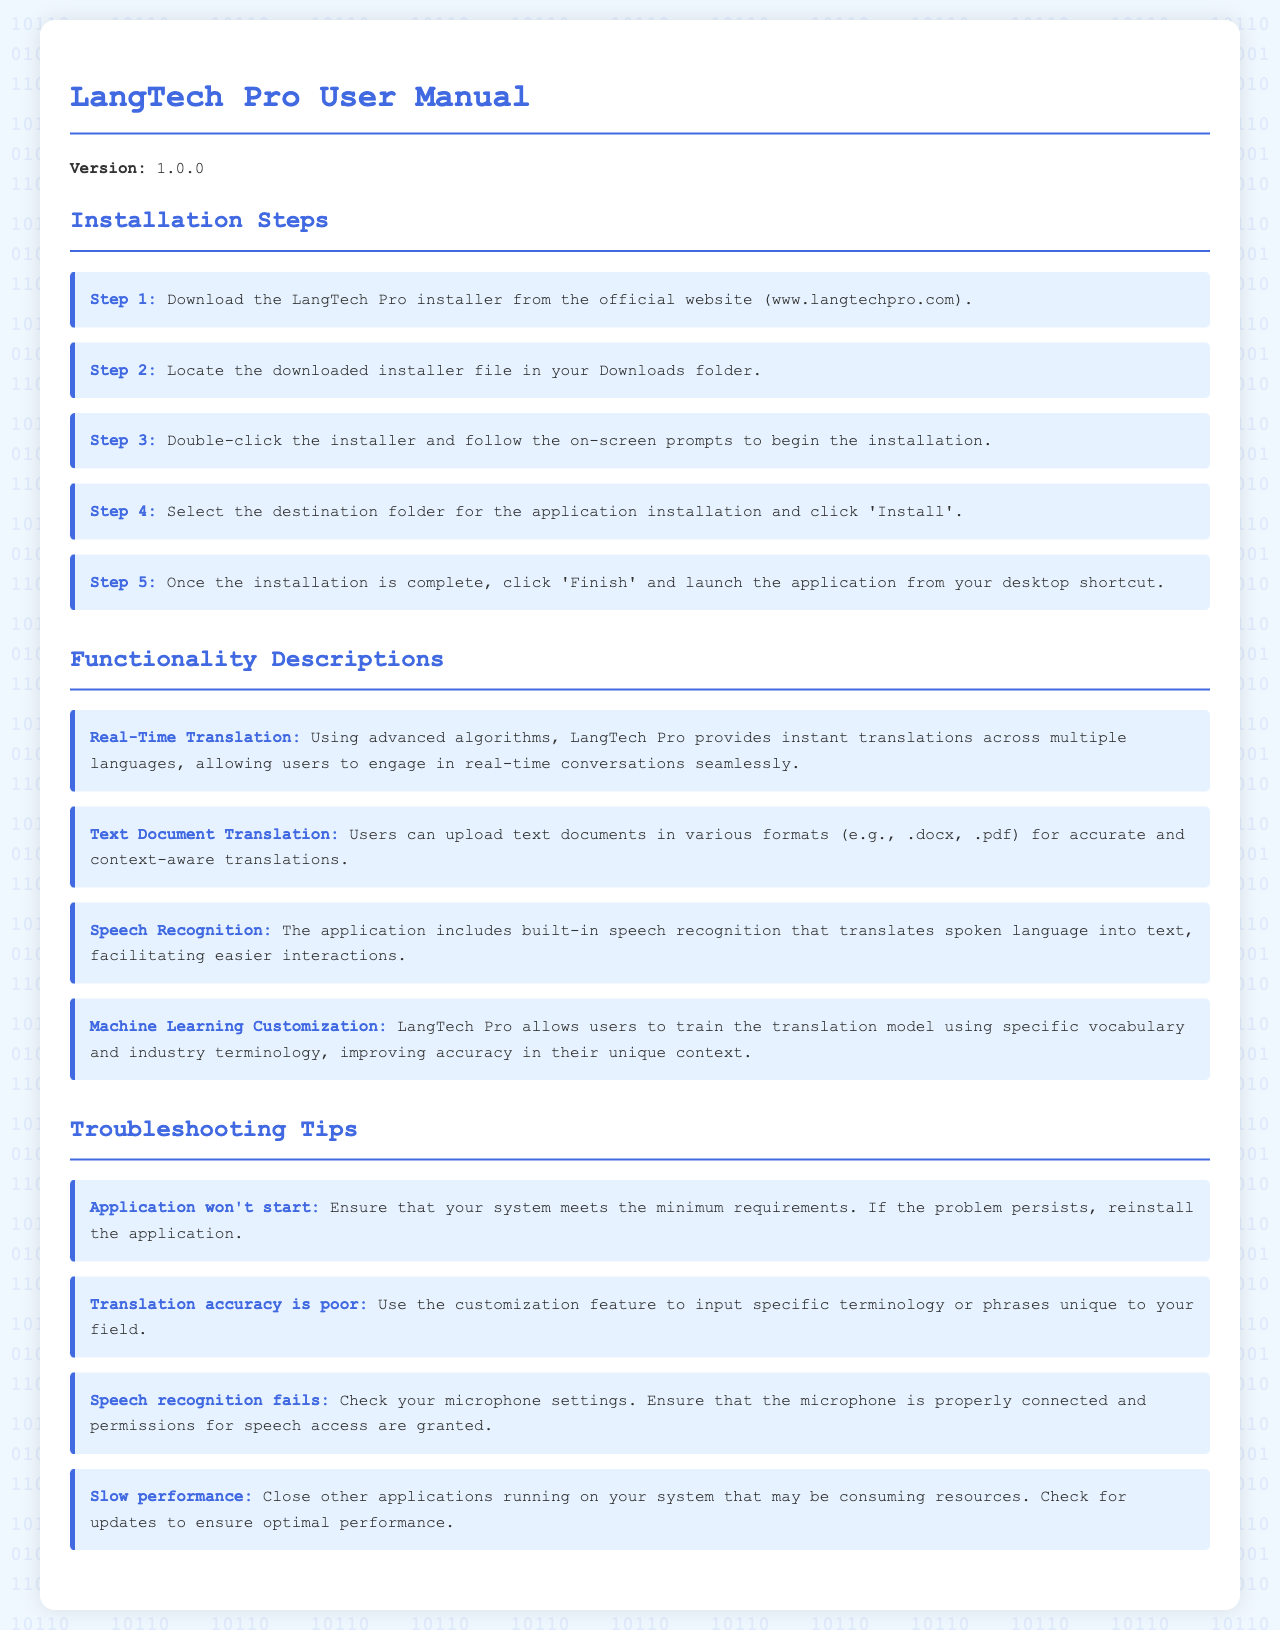What is the version of LangTech Pro? The version of LangTech Pro is explicitly mentioned in the document as 1.0.0.
Answer: 1.0.0 What is the first step in the installation process? The first step in the installation process is to download the LangTech Pro installer from the official website.
Answer: Download the LangTech Pro installer How many functionality descriptions are listed in the document? The document describes four distinct functionalities, which are listed under the functionality descriptions section.
Answer: Four What troubleshooting tip is suggested for when the application won't start? The tip suggests ensuring that your system meets the minimum requirements and, if the problem persists, to reinstall the application.
Answer: Reinstall the application What feature allows users to upload text documents? The feature that allows users to upload text documents is called Text Document Translation.
Answer: Text Document Translation What should you check if the speech recognition fails? If speech recognition fails, you should check your microphone settings and permissions for speech access.
Answer: Microphone settings What is the last step of the installation process? The last step of the installation process is to click 'Finish' and launch the application from your desktop shortcut.
Answer: Click 'Finish' and launch the application What problem might cause slow performance according to the troubleshooting tips? Closing other applications running on your system that may be consuming resources could solve slow performance issues.
Answer: Close other applications Which feature customizes the translation model? The feature that customizes the translation model is called Machine Learning Customization.
Answer: Machine Learning Customization 